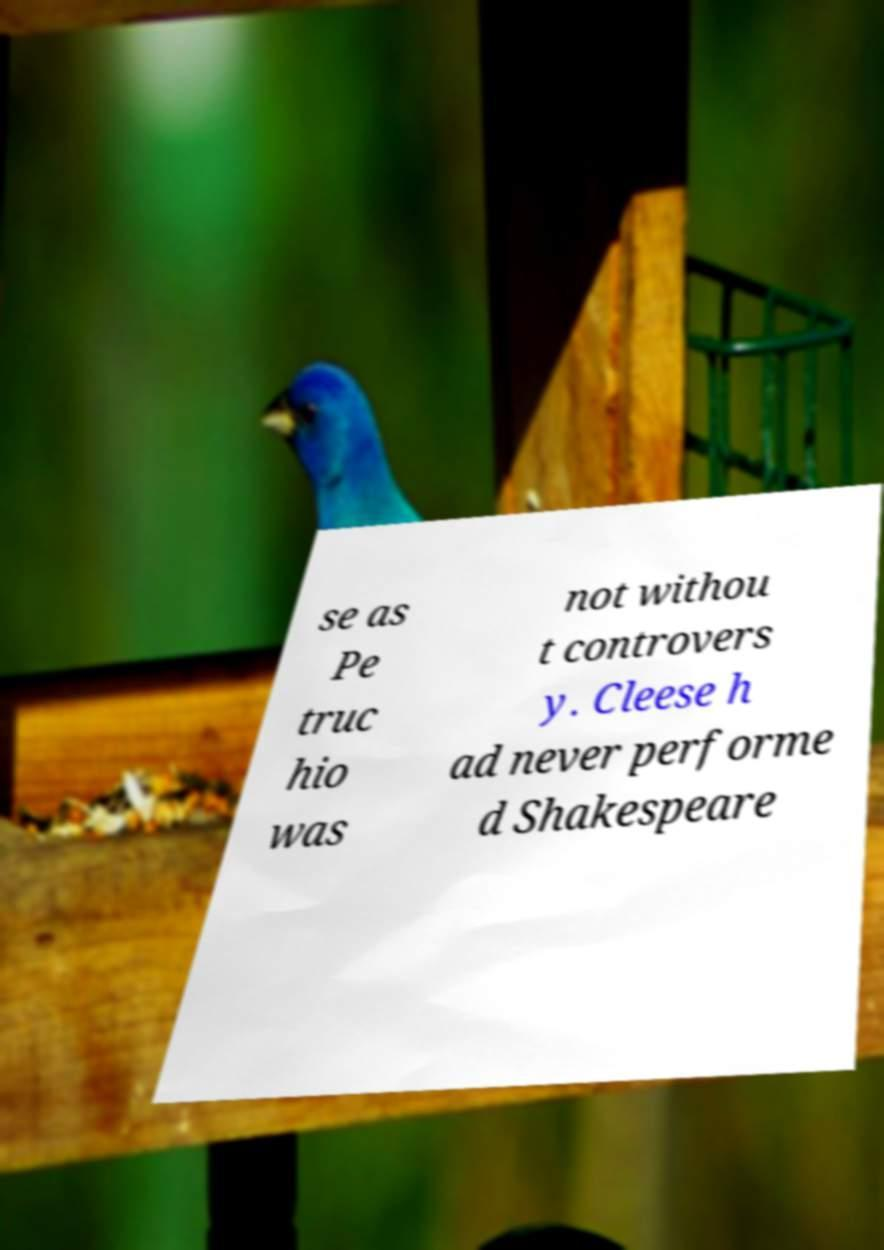Please read and relay the text visible in this image. What does it say? se as Pe truc hio was not withou t controvers y. Cleese h ad never performe d Shakespeare 